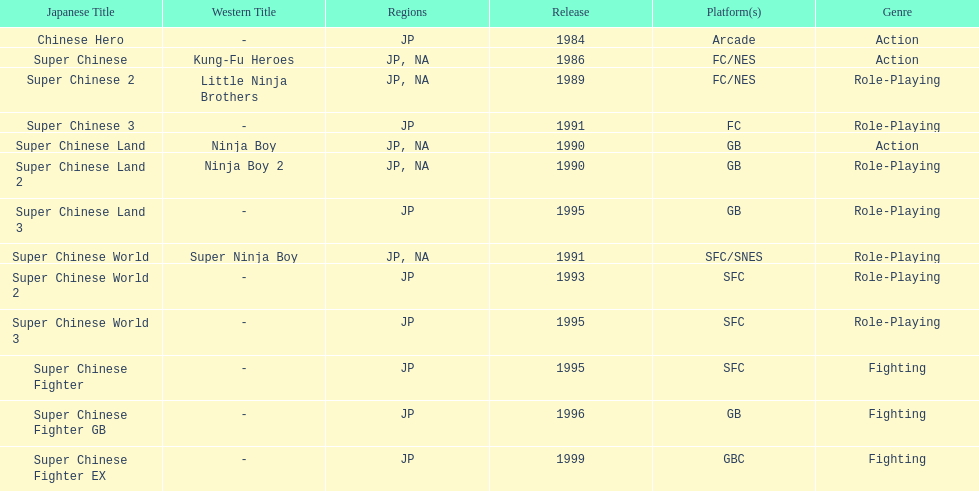Out of the titles made available in north america, which had the smallest amount of releases? Super Chinese World. 